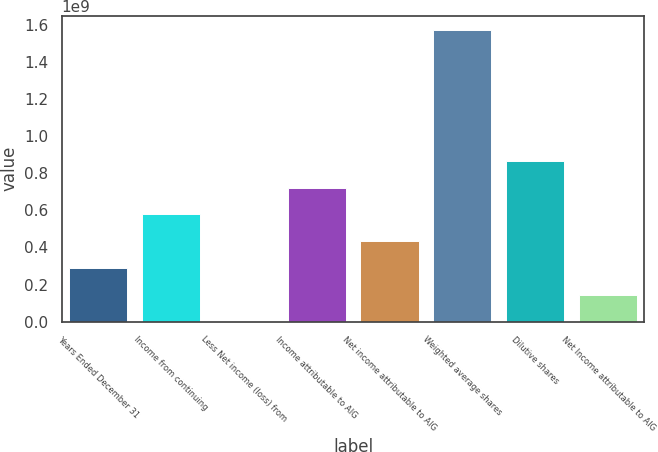Convert chart to OTSL. <chart><loc_0><loc_0><loc_500><loc_500><bar_chart><fcel>Years Ended December 31<fcel>Income from continuing<fcel>Less Net income (loss) from<fcel>Income attributable to AIG<fcel>Net income attributable to AIG<fcel>Weighted average shares<fcel>Dilutive shares<fcel>Net Income attributable to AIG<nl><fcel>2.89511e+08<fcel>5.79021e+08<fcel>5<fcel>7.23777e+08<fcel>4.34266e+08<fcel>1.57272e+09<fcel>8.68532e+08<fcel>1.44755e+08<nl></chart> 